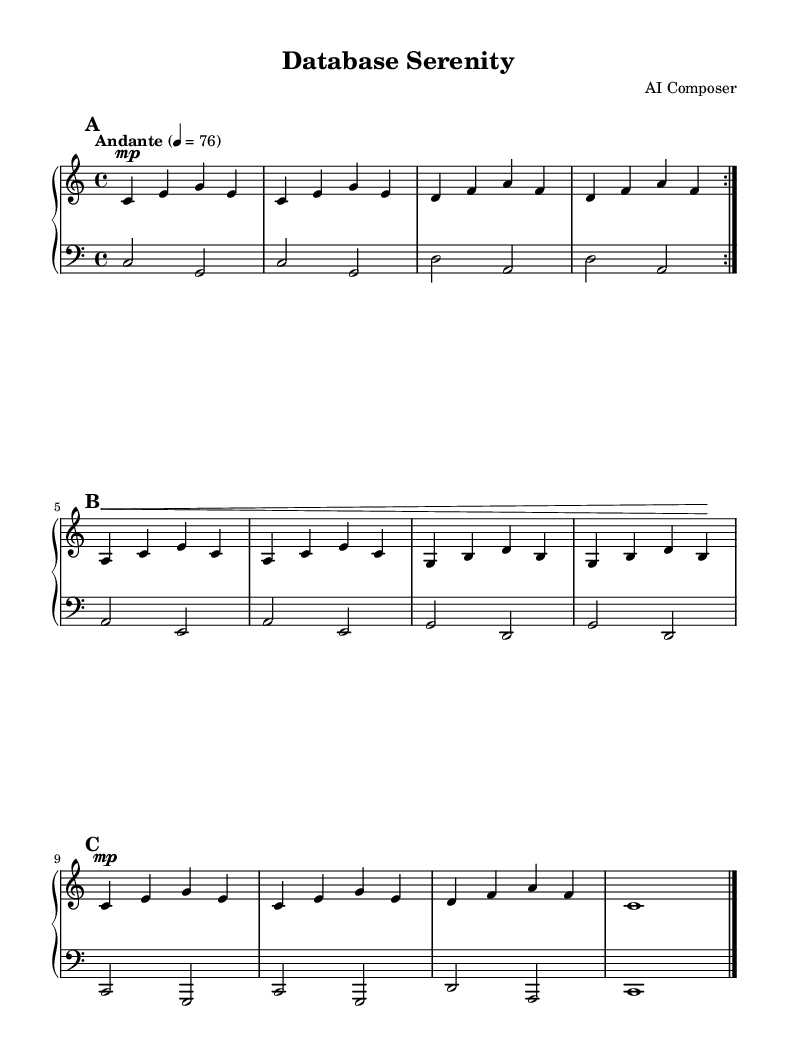What is the key signature of this music? The key signature is C major, which has no sharps or flats, as indicated by the absence of any accidentals in the music.
Answer: C major What is the time signature of this music? The time signature indicated at the beginning of the score is 4/4, meaning there are four beats in each measure and the quarter note gets one beat.
Answer: 4/4 What is the tempo marking of this music? The tempo marking at the beginning states "Andante," which indicates a moderately slow pace, typically around 76 beats per minute.
Answer: Andante How many sections are in this composition? The composition has three main sections: A, B, and A'', which are labeled through their repetitions and differs in the melody structure.
Answer: Three What is the note duration of the longest note in the A'' section? The longest note in the A'' section is a whole note written as 'c1,' which indicates it lasts for four beats in 4/4 time.
Answer: Whole note Which instruments are indicated for this composition? The instruments indicated for this composition are two piano staves, typically played on an acoustic grand piano, as noted in the score setup.
Answer: Acoustic grand What dynamics are indicated for the right hand in the A section? The right hand in the A section is marked as 'mp', which means mezzo-piano, indicating a moderately soft volume throughout this part.
Answer: Mezzo-piano 